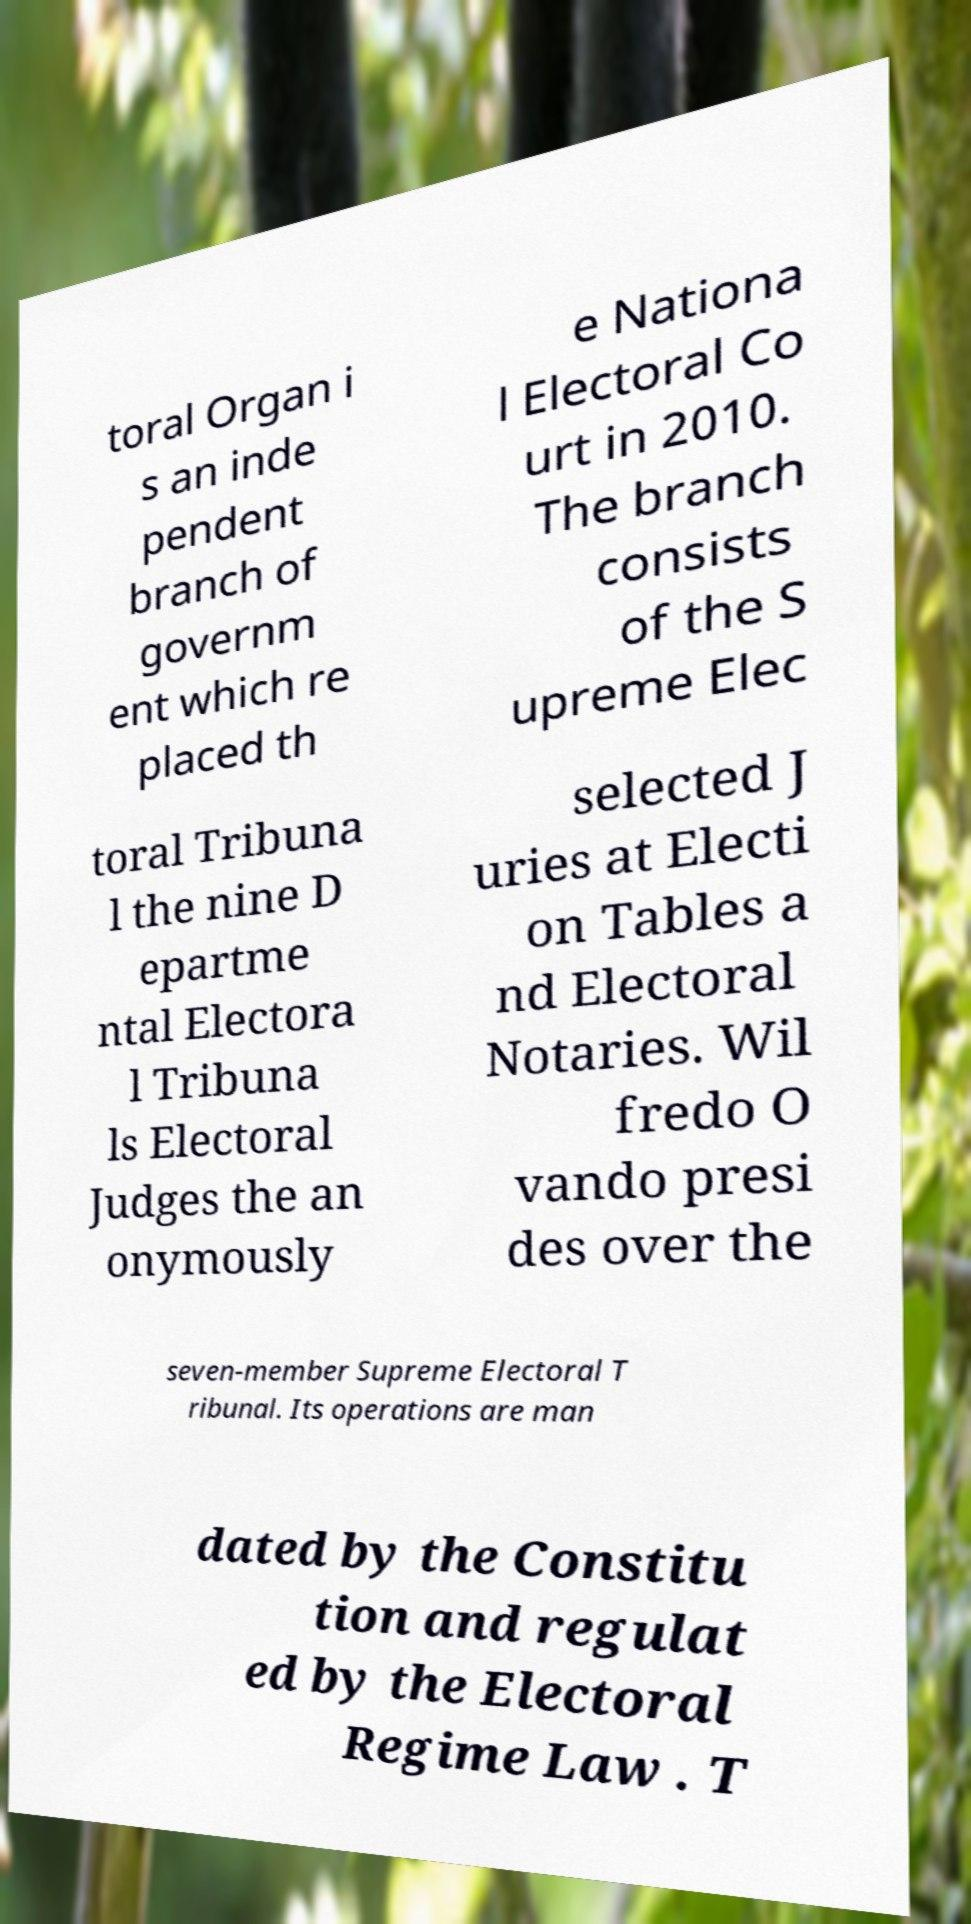Please read and relay the text visible in this image. What does it say? toral Organ i s an inde pendent branch of governm ent which re placed th e Nationa l Electoral Co urt in 2010. The branch consists of the S upreme Elec toral Tribuna l the nine D epartme ntal Electora l Tribuna ls Electoral Judges the an onymously selected J uries at Electi on Tables a nd Electoral Notaries. Wil fredo O vando presi des over the seven-member Supreme Electoral T ribunal. Its operations are man dated by the Constitu tion and regulat ed by the Electoral Regime Law . T 